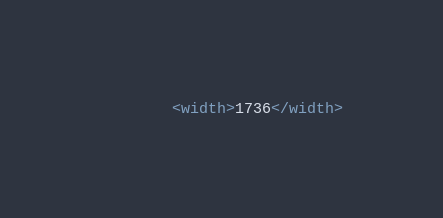<code> <loc_0><loc_0><loc_500><loc_500><_XML_>		<width>1736</width></code> 